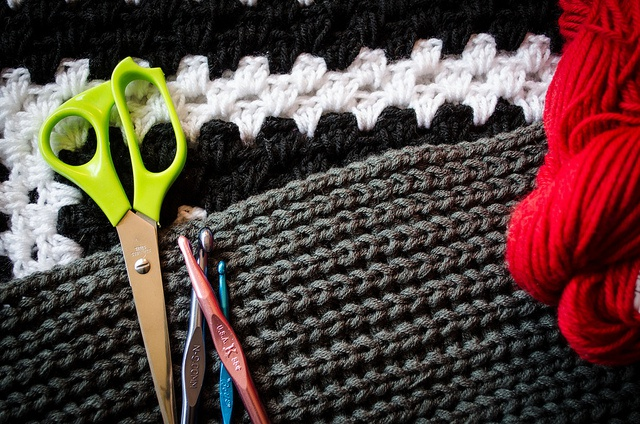Describe the objects in this image and their specific colors. I can see scissors in black, yellow, tan, and olive tones in this image. 